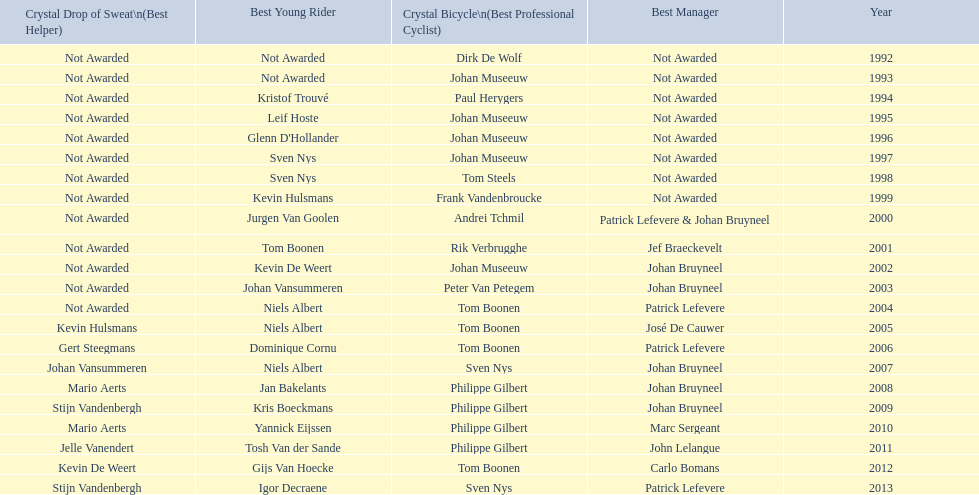What is the average number of times johan museeuw starred? 5. 